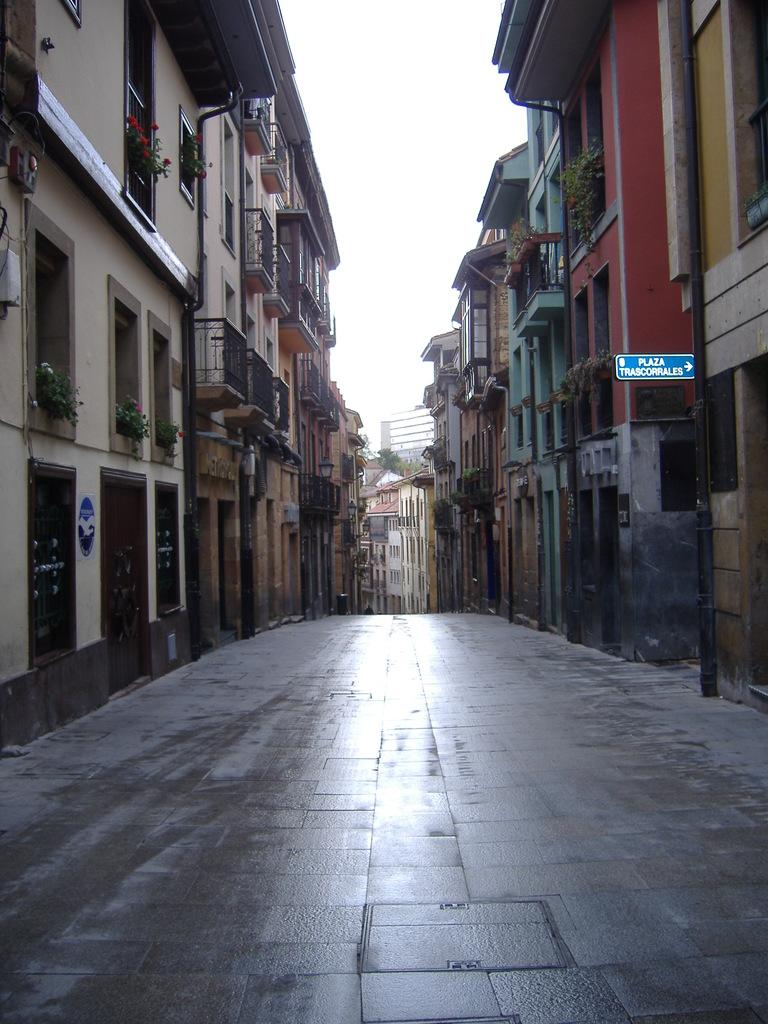What type of structures can be seen in the image? There are buildings in the image. What type of vegetation is present in the image? There are houseplants and trees in the image. What type of signage is visible in the image? There are sign boards in the image. What type of infrastructure is present in the image? There are pipelines in the image. What type of architectural features can be seen in the image? There are railings, doors, and windows in the image. What part of the natural environment is visible in the image? The sky is visible in the image. What type of creature is shown expanding in the image? There is no creature present in the image, and no expansion is depicted. 